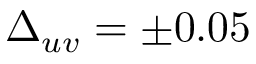Convert formula to latex. <formula><loc_0><loc_0><loc_500><loc_500>\Delta _ { u v } = \pm 0 . 0 5</formula> 